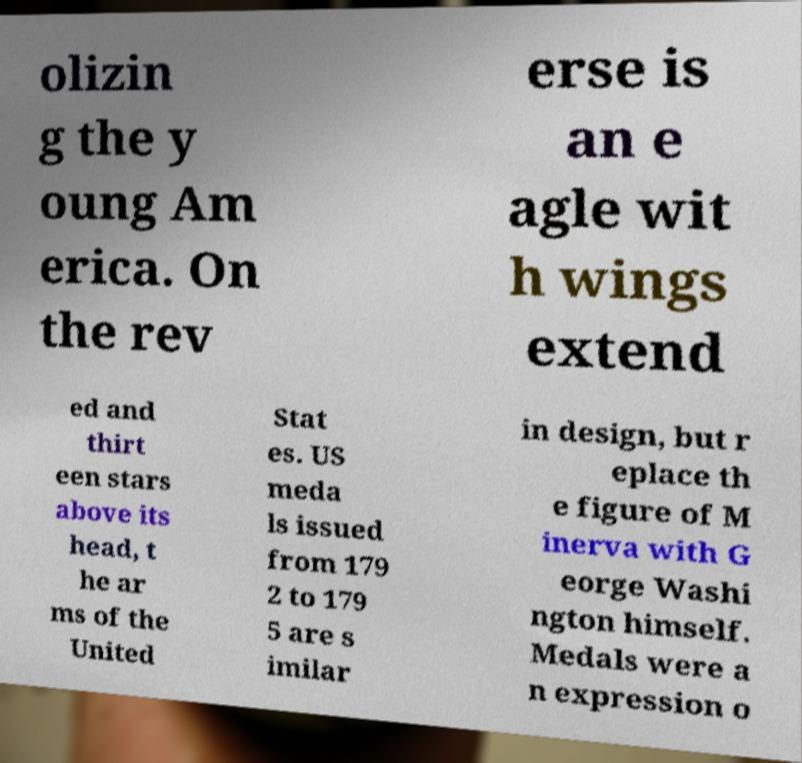I need the written content from this picture converted into text. Can you do that? olizin g the y oung Am erica. On the rev erse is an e agle wit h wings extend ed and thirt een stars above its head, t he ar ms of the United Stat es. US meda ls issued from 179 2 to 179 5 are s imilar in design, but r eplace th e figure of M inerva with G eorge Washi ngton himself. Medals were a n expression o 